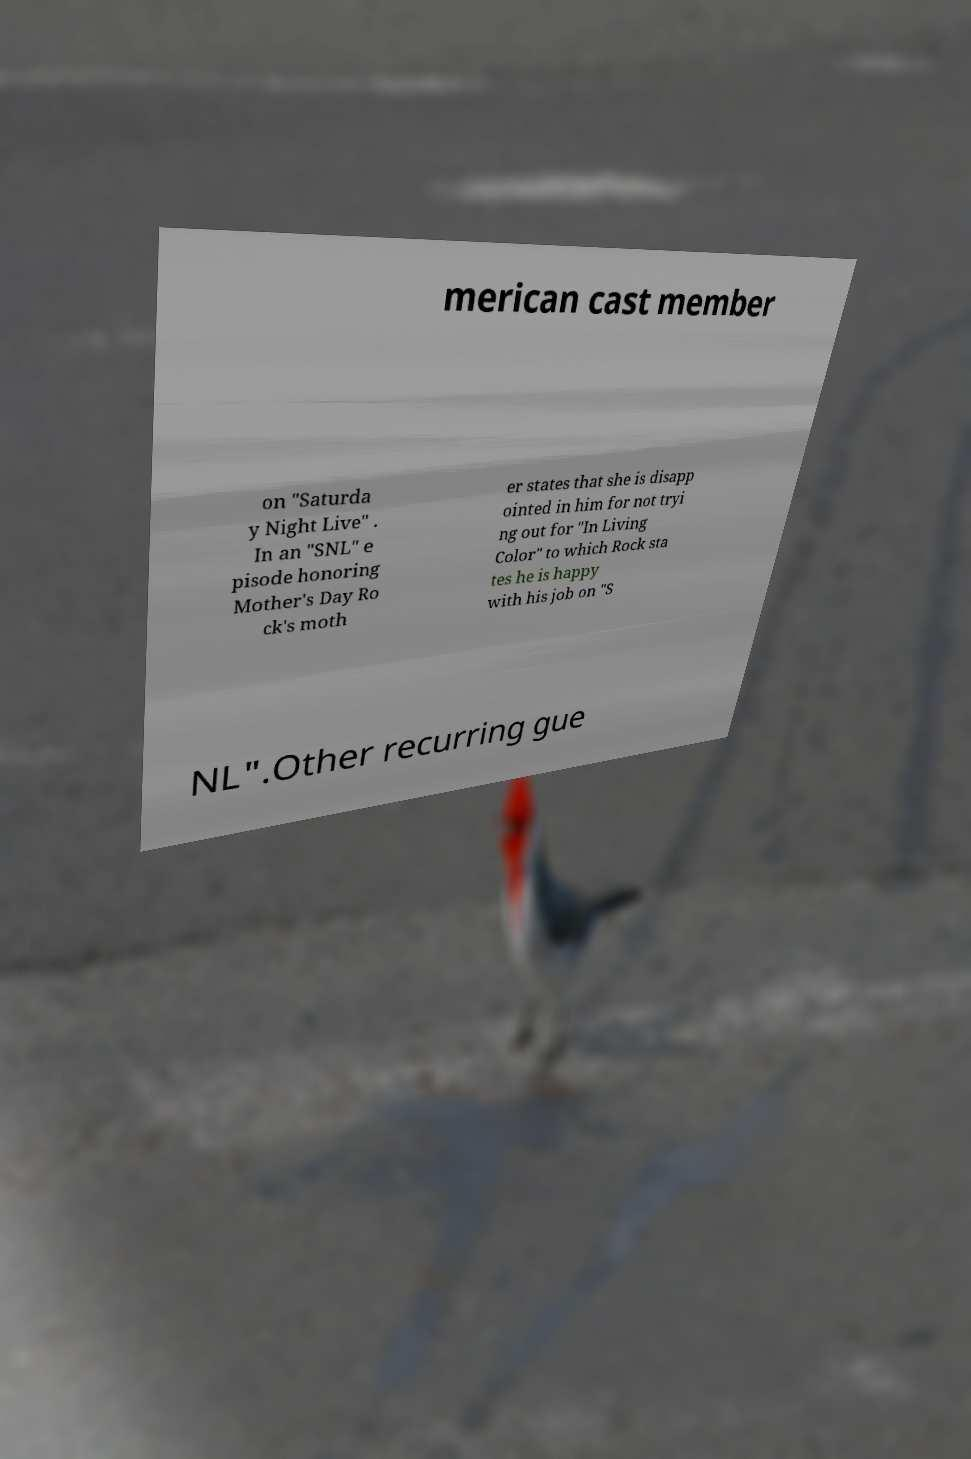Please read and relay the text visible in this image. What does it say? merican cast member on "Saturda y Night Live" . In an "SNL" e pisode honoring Mother's Day Ro ck's moth er states that she is disapp ointed in him for not tryi ng out for "In Living Color" to which Rock sta tes he is happy with his job on "S NL".Other recurring gue 